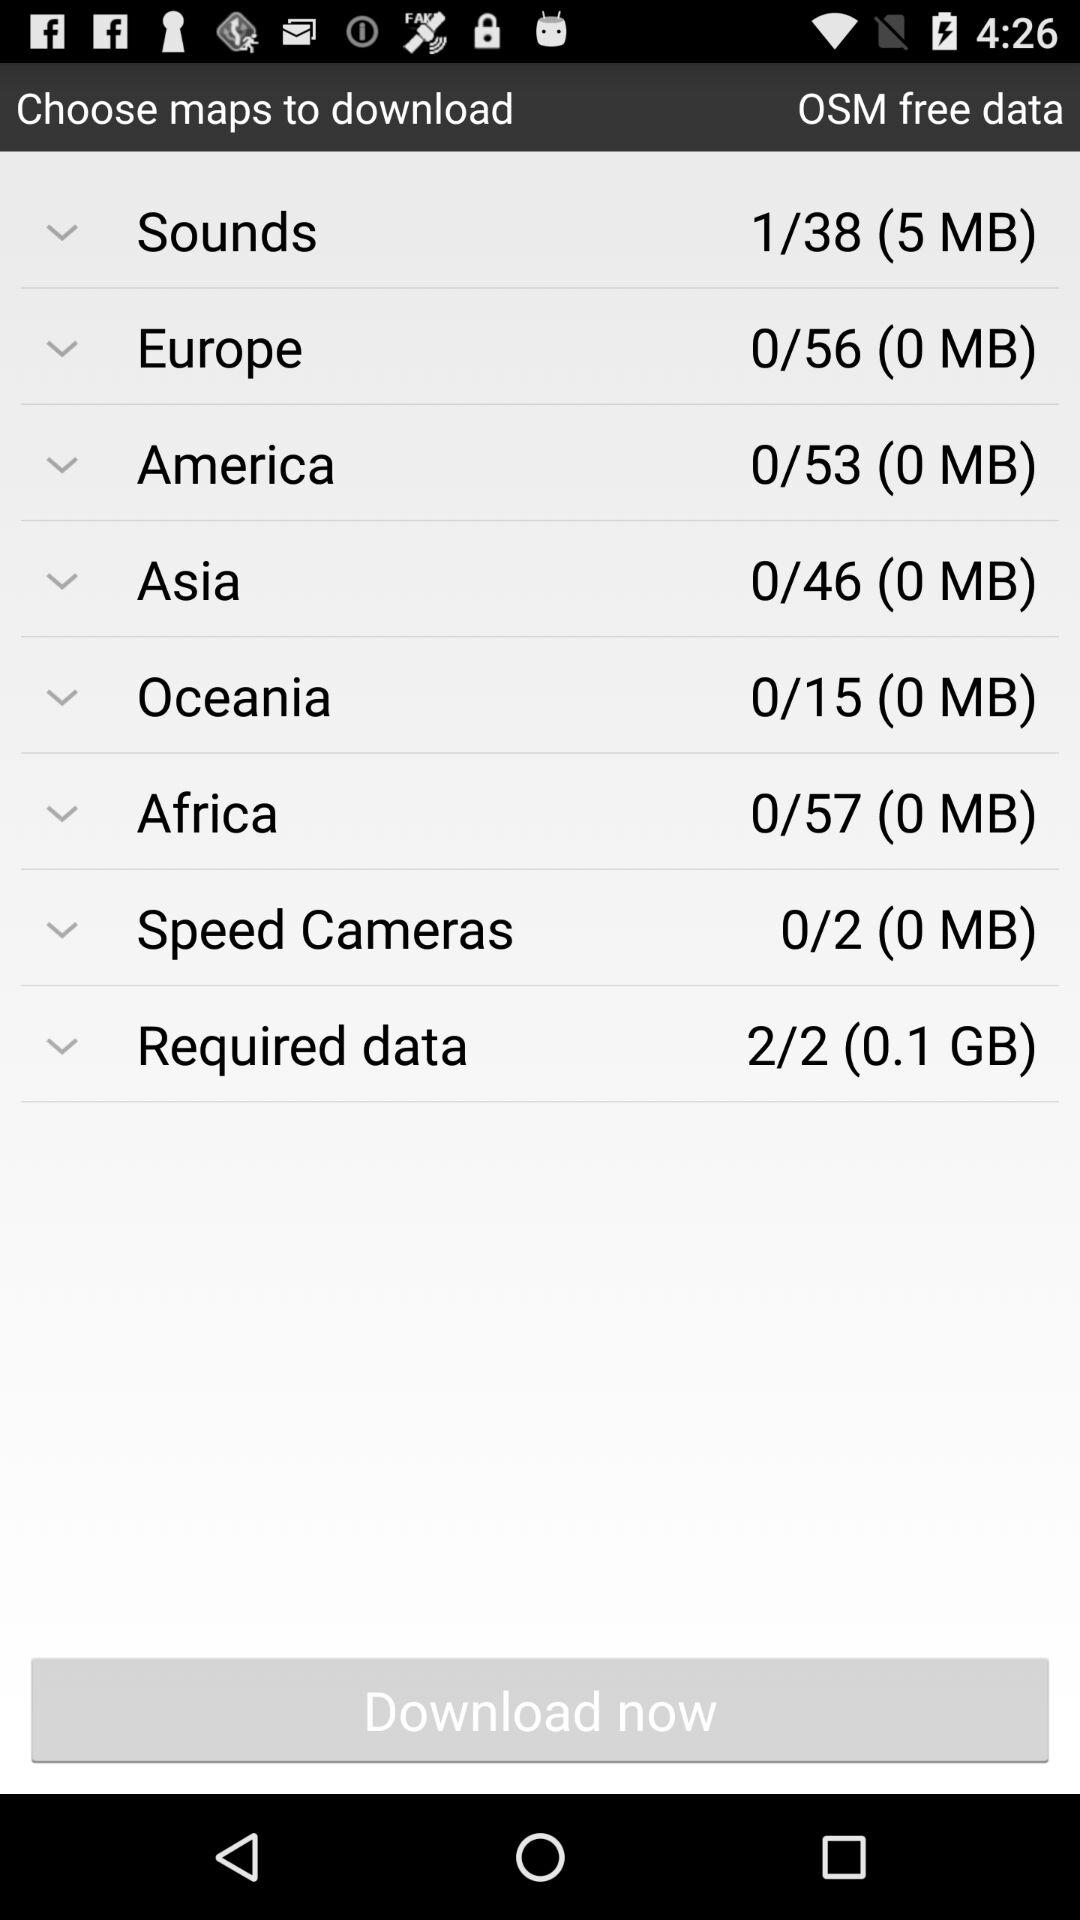How much data is required to download all of the maps?
Answer the question using a single word or phrase. 0.1 GB 